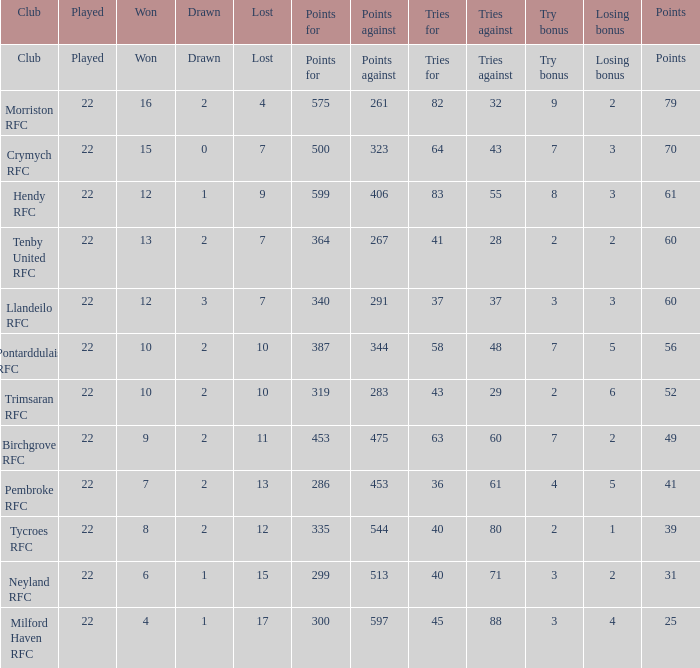 how many points against with tries for being 43 1.0. 